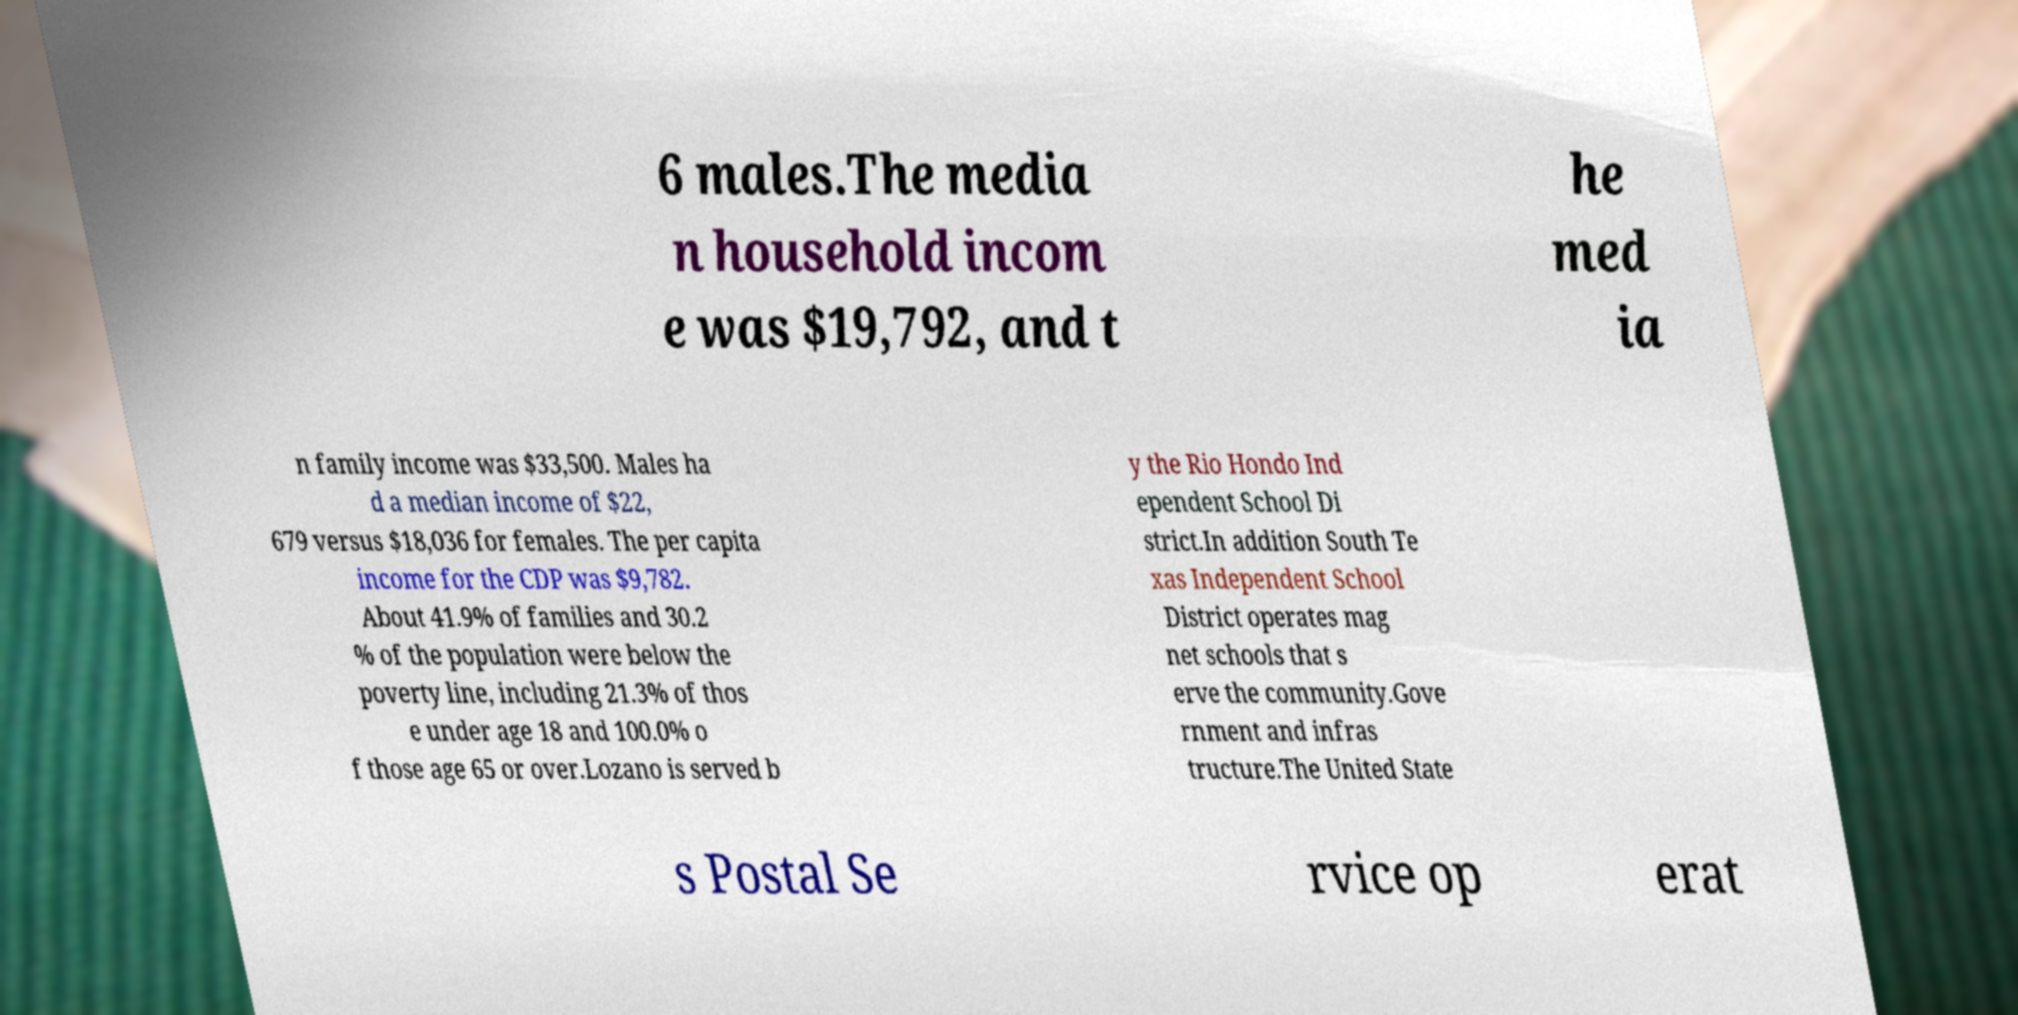Can you read and provide the text displayed in the image?This photo seems to have some interesting text. Can you extract and type it out for me? 6 males.The media n household incom e was $19,792, and t he med ia n family income was $33,500. Males ha d a median income of $22, 679 versus $18,036 for females. The per capita income for the CDP was $9,782. About 41.9% of families and 30.2 % of the population were below the poverty line, including 21.3% of thos e under age 18 and 100.0% o f those age 65 or over.Lozano is served b y the Rio Hondo Ind ependent School Di strict.In addition South Te xas Independent School District operates mag net schools that s erve the community.Gove rnment and infras tructure.The United State s Postal Se rvice op erat 